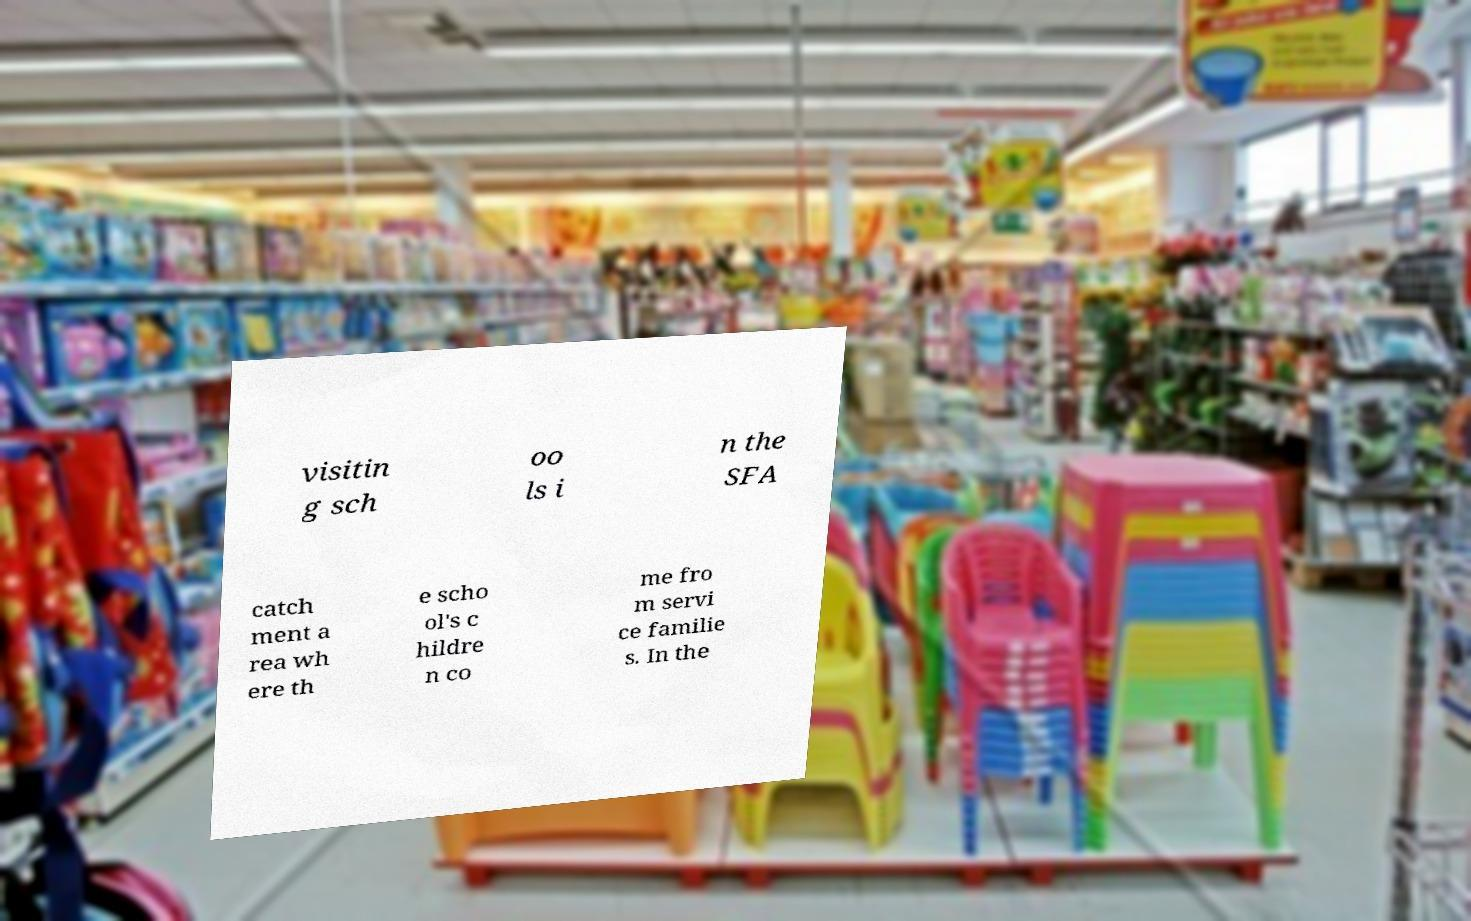Could you extract and type out the text from this image? visitin g sch oo ls i n the SFA catch ment a rea wh ere th e scho ol's c hildre n co me fro m servi ce familie s. In the 